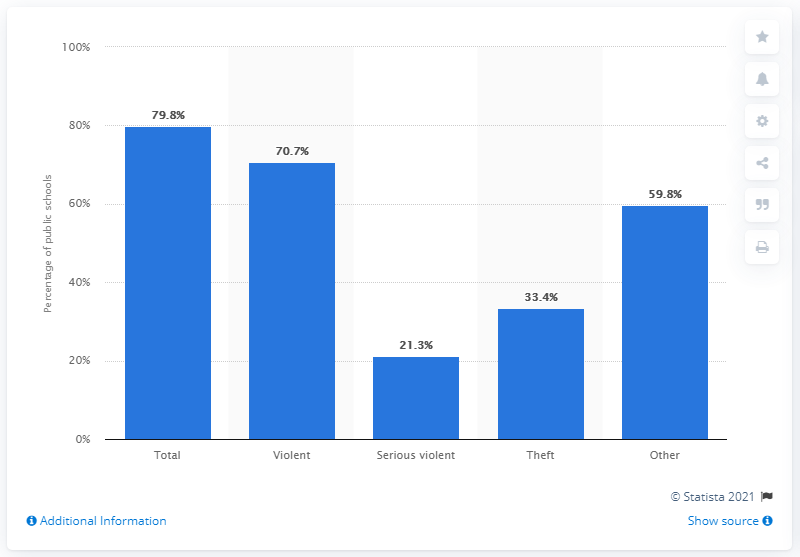Specify some key components in this picture. According to data, approximately 33.4% of public schools recorded a theft. 